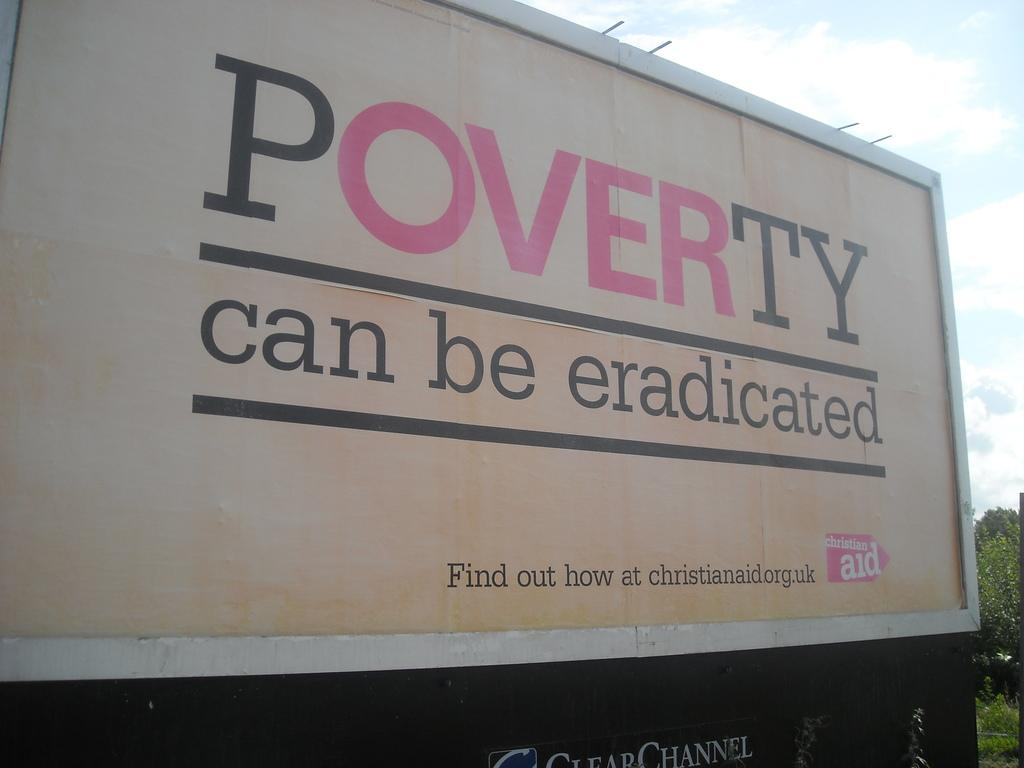Provide a one-sentence caption for the provided image. The side of a truck is advocating against poverty. 